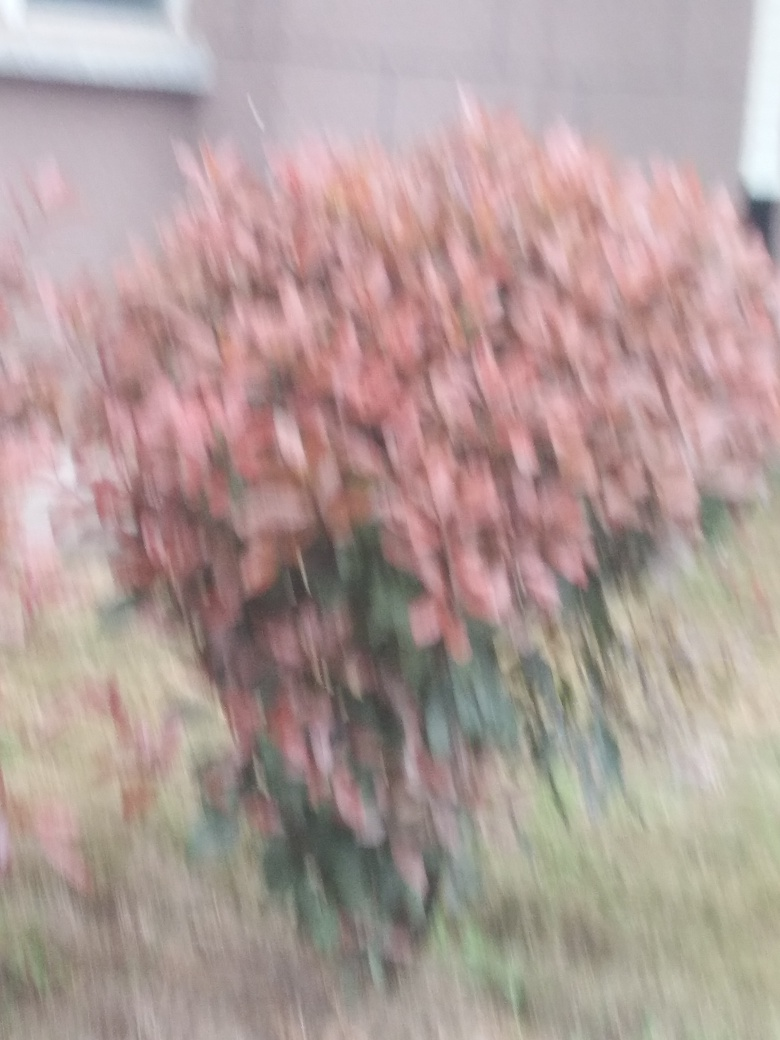Could this image's blurriness be intentional for artistic effect, and if so, how might it evoke a particular mood or idea? Although this image appears blurry, if done intentionally, it can convey a sense of motion, dreaminess, or ethereal quality. The blurriness could evoke the fleeting nature of memories or the passage of time. This technique might be used by artists to challenge viewers' perceptions or to encourage a focus on colors and impressions over clear details. 